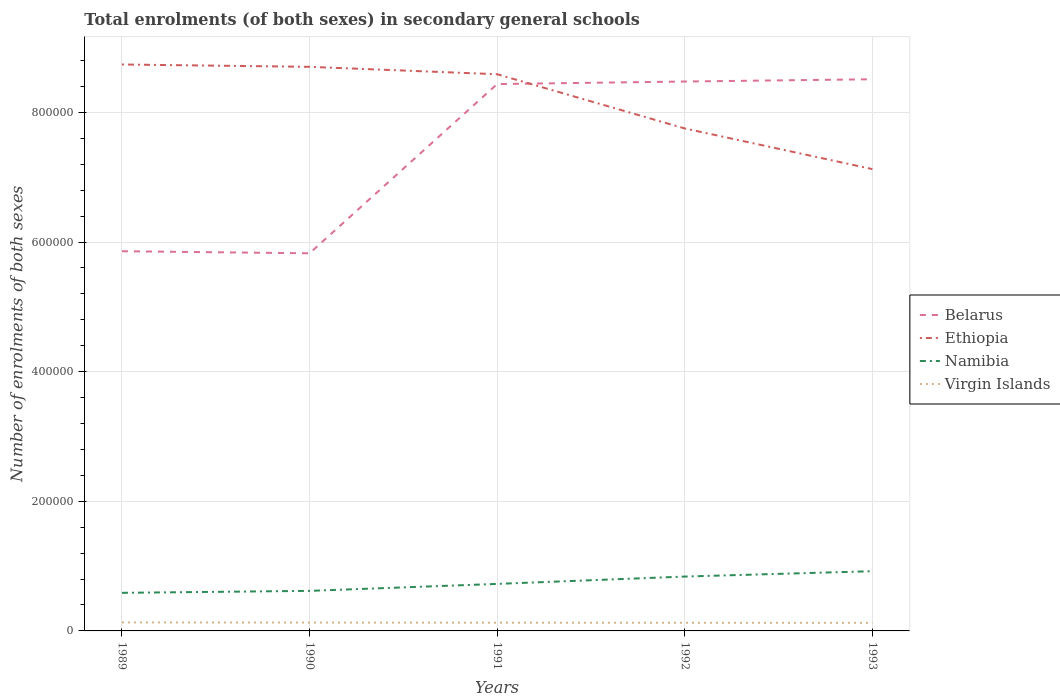Across all years, what is the maximum number of enrolments in secondary schools in Belarus?
Give a very brief answer. 5.83e+05. In which year was the number of enrolments in secondary schools in Namibia maximum?
Ensure brevity in your answer.  1989. What is the total number of enrolments in secondary schools in Namibia in the graph?
Offer a very short reply. -1.38e+04. What is the difference between the highest and the second highest number of enrolments in secondary schools in Namibia?
Make the answer very short. 3.34e+04. What is the difference between the highest and the lowest number of enrolments in secondary schools in Belarus?
Your response must be concise. 3. Is the number of enrolments in secondary schools in Belarus strictly greater than the number of enrolments in secondary schools in Ethiopia over the years?
Provide a succinct answer. No. How many legend labels are there?
Offer a terse response. 4. What is the title of the graph?
Your answer should be very brief. Total enrolments (of both sexes) in secondary general schools. Does "South Asia" appear as one of the legend labels in the graph?
Give a very brief answer. No. What is the label or title of the X-axis?
Offer a very short reply. Years. What is the label or title of the Y-axis?
Your answer should be compact. Number of enrolments of both sexes. What is the Number of enrolments of both sexes of Belarus in 1989?
Your answer should be very brief. 5.86e+05. What is the Number of enrolments of both sexes of Ethiopia in 1989?
Offer a terse response. 8.74e+05. What is the Number of enrolments of both sexes in Namibia in 1989?
Provide a short and direct response. 5.88e+04. What is the Number of enrolments of both sexes of Virgin Islands in 1989?
Keep it short and to the point. 1.31e+04. What is the Number of enrolments of both sexes in Belarus in 1990?
Your answer should be compact. 5.83e+05. What is the Number of enrolments of both sexes of Ethiopia in 1990?
Offer a very short reply. 8.70e+05. What is the Number of enrolments of both sexes in Namibia in 1990?
Give a very brief answer. 6.18e+04. What is the Number of enrolments of both sexes in Virgin Islands in 1990?
Give a very brief answer. 1.29e+04. What is the Number of enrolments of both sexes of Belarus in 1991?
Offer a terse response. 8.44e+05. What is the Number of enrolments of both sexes in Ethiopia in 1991?
Provide a short and direct response. 8.59e+05. What is the Number of enrolments of both sexes in Namibia in 1991?
Your answer should be very brief. 7.25e+04. What is the Number of enrolments of both sexes in Virgin Islands in 1991?
Your response must be concise. 1.27e+04. What is the Number of enrolments of both sexes in Belarus in 1992?
Your response must be concise. 8.48e+05. What is the Number of enrolments of both sexes in Ethiopia in 1992?
Your answer should be very brief. 7.75e+05. What is the Number of enrolments of both sexes in Namibia in 1992?
Ensure brevity in your answer.  8.39e+04. What is the Number of enrolments of both sexes of Virgin Islands in 1992?
Offer a very short reply. 1.26e+04. What is the Number of enrolments of both sexes of Belarus in 1993?
Provide a succinct answer. 8.51e+05. What is the Number of enrolments of both sexes of Ethiopia in 1993?
Provide a short and direct response. 7.12e+05. What is the Number of enrolments of both sexes of Namibia in 1993?
Your answer should be very brief. 9.21e+04. What is the Number of enrolments of both sexes of Virgin Islands in 1993?
Your answer should be very brief. 1.25e+04. Across all years, what is the maximum Number of enrolments of both sexes of Belarus?
Give a very brief answer. 8.51e+05. Across all years, what is the maximum Number of enrolments of both sexes of Ethiopia?
Your response must be concise. 8.74e+05. Across all years, what is the maximum Number of enrolments of both sexes of Namibia?
Provide a short and direct response. 9.21e+04. Across all years, what is the maximum Number of enrolments of both sexes of Virgin Islands?
Your answer should be compact. 1.31e+04. Across all years, what is the minimum Number of enrolments of both sexes in Belarus?
Keep it short and to the point. 5.83e+05. Across all years, what is the minimum Number of enrolments of both sexes in Ethiopia?
Your answer should be very brief. 7.12e+05. Across all years, what is the minimum Number of enrolments of both sexes of Namibia?
Offer a very short reply. 5.88e+04. Across all years, what is the minimum Number of enrolments of both sexes of Virgin Islands?
Provide a short and direct response. 1.25e+04. What is the total Number of enrolments of both sexes of Belarus in the graph?
Keep it short and to the point. 3.71e+06. What is the total Number of enrolments of both sexes in Ethiopia in the graph?
Give a very brief answer. 4.09e+06. What is the total Number of enrolments of both sexes in Namibia in the graph?
Keep it short and to the point. 3.69e+05. What is the total Number of enrolments of both sexes of Virgin Islands in the graph?
Offer a very short reply. 6.38e+04. What is the difference between the Number of enrolments of both sexes of Belarus in 1989 and that in 1990?
Make the answer very short. 3200. What is the difference between the Number of enrolments of both sexes of Ethiopia in 1989 and that in 1990?
Give a very brief answer. 3614. What is the difference between the Number of enrolments of both sexes of Namibia in 1989 and that in 1990?
Offer a terse response. -3032. What is the difference between the Number of enrolments of both sexes in Belarus in 1989 and that in 1991?
Your response must be concise. -2.58e+05. What is the difference between the Number of enrolments of both sexes in Ethiopia in 1989 and that in 1991?
Your answer should be very brief. 1.50e+04. What is the difference between the Number of enrolments of both sexes of Namibia in 1989 and that in 1991?
Keep it short and to the point. -1.38e+04. What is the difference between the Number of enrolments of both sexes of Belarus in 1989 and that in 1992?
Give a very brief answer. -2.62e+05. What is the difference between the Number of enrolments of both sexes of Ethiopia in 1989 and that in 1992?
Provide a short and direct response. 9.87e+04. What is the difference between the Number of enrolments of both sexes in Namibia in 1989 and that in 1992?
Your answer should be very brief. -2.51e+04. What is the difference between the Number of enrolments of both sexes in Virgin Islands in 1989 and that in 1992?
Your answer should be compact. 500. What is the difference between the Number of enrolments of both sexes of Belarus in 1989 and that in 1993?
Give a very brief answer. -2.65e+05. What is the difference between the Number of enrolments of both sexes in Ethiopia in 1989 and that in 1993?
Provide a short and direct response. 1.61e+05. What is the difference between the Number of enrolments of both sexes in Namibia in 1989 and that in 1993?
Your answer should be compact. -3.34e+04. What is the difference between the Number of enrolments of both sexes of Virgin Islands in 1989 and that in 1993?
Provide a succinct answer. 598. What is the difference between the Number of enrolments of both sexes in Belarus in 1990 and that in 1991?
Your response must be concise. -2.61e+05. What is the difference between the Number of enrolments of both sexes of Ethiopia in 1990 and that in 1991?
Your answer should be compact. 1.14e+04. What is the difference between the Number of enrolments of both sexes in Namibia in 1990 and that in 1991?
Your answer should be compact. -1.07e+04. What is the difference between the Number of enrolments of both sexes in Belarus in 1990 and that in 1992?
Offer a terse response. -2.65e+05. What is the difference between the Number of enrolments of both sexes of Ethiopia in 1990 and that in 1992?
Provide a short and direct response. 9.51e+04. What is the difference between the Number of enrolments of both sexes of Namibia in 1990 and that in 1992?
Keep it short and to the point. -2.21e+04. What is the difference between the Number of enrolments of both sexes in Virgin Islands in 1990 and that in 1992?
Offer a very short reply. 300. What is the difference between the Number of enrolments of both sexes in Belarus in 1990 and that in 1993?
Make the answer very short. -2.68e+05. What is the difference between the Number of enrolments of both sexes of Ethiopia in 1990 and that in 1993?
Make the answer very short. 1.58e+05. What is the difference between the Number of enrolments of both sexes in Namibia in 1990 and that in 1993?
Your answer should be very brief. -3.03e+04. What is the difference between the Number of enrolments of both sexes in Virgin Islands in 1990 and that in 1993?
Offer a very short reply. 398. What is the difference between the Number of enrolments of both sexes of Belarus in 1991 and that in 1992?
Provide a succinct answer. -3900. What is the difference between the Number of enrolments of both sexes in Ethiopia in 1991 and that in 1992?
Your response must be concise. 8.36e+04. What is the difference between the Number of enrolments of both sexes of Namibia in 1991 and that in 1992?
Your response must be concise. -1.13e+04. What is the difference between the Number of enrolments of both sexes in Belarus in 1991 and that in 1993?
Ensure brevity in your answer.  -7400. What is the difference between the Number of enrolments of both sexes of Ethiopia in 1991 and that in 1993?
Keep it short and to the point. 1.46e+05. What is the difference between the Number of enrolments of both sexes in Namibia in 1991 and that in 1993?
Provide a succinct answer. -1.96e+04. What is the difference between the Number of enrolments of both sexes in Virgin Islands in 1991 and that in 1993?
Offer a very short reply. 198. What is the difference between the Number of enrolments of both sexes in Belarus in 1992 and that in 1993?
Keep it short and to the point. -3500. What is the difference between the Number of enrolments of both sexes of Ethiopia in 1992 and that in 1993?
Provide a short and direct response. 6.27e+04. What is the difference between the Number of enrolments of both sexes in Namibia in 1992 and that in 1993?
Keep it short and to the point. -8274. What is the difference between the Number of enrolments of both sexes in Virgin Islands in 1992 and that in 1993?
Offer a very short reply. 98. What is the difference between the Number of enrolments of both sexes of Belarus in 1989 and the Number of enrolments of both sexes of Ethiopia in 1990?
Ensure brevity in your answer.  -2.84e+05. What is the difference between the Number of enrolments of both sexes of Belarus in 1989 and the Number of enrolments of both sexes of Namibia in 1990?
Offer a very short reply. 5.24e+05. What is the difference between the Number of enrolments of both sexes of Belarus in 1989 and the Number of enrolments of both sexes of Virgin Islands in 1990?
Offer a terse response. 5.73e+05. What is the difference between the Number of enrolments of both sexes of Ethiopia in 1989 and the Number of enrolments of both sexes of Namibia in 1990?
Ensure brevity in your answer.  8.12e+05. What is the difference between the Number of enrolments of both sexes in Ethiopia in 1989 and the Number of enrolments of both sexes in Virgin Islands in 1990?
Provide a short and direct response. 8.61e+05. What is the difference between the Number of enrolments of both sexes of Namibia in 1989 and the Number of enrolments of both sexes of Virgin Islands in 1990?
Keep it short and to the point. 4.59e+04. What is the difference between the Number of enrolments of both sexes in Belarus in 1989 and the Number of enrolments of both sexes in Ethiopia in 1991?
Offer a terse response. -2.73e+05. What is the difference between the Number of enrolments of both sexes in Belarus in 1989 and the Number of enrolments of both sexes in Namibia in 1991?
Your answer should be compact. 5.13e+05. What is the difference between the Number of enrolments of both sexes of Belarus in 1989 and the Number of enrolments of both sexes of Virgin Islands in 1991?
Your answer should be very brief. 5.73e+05. What is the difference between the Number of enrolments of both sexes in Ethiopia in 1989 and the Number of enrolments of both sexes in Namibia in 1991?
Offer a terse response. 8.01e+05. What is the difference between the Number of enrolments of both sexes of Ethiopia in 1989 and the Number of enrolments of both sexes of Virgin Islands in 1991?
Keep it short and to the point. 8.61e+05. What is the difference between the Number of enrolments of both sexes of Namibia in 1989 and the Number of enrolments of both sexes of Virgin Islands in 1991?
Your answer should be very brief. 4.61e+04. What is the difference between the Number of enrolments of both sexes in Belarus in 1989 and the Number of enrolments of both sexes in Ethiopia in 1992?
Ensure brevity in your answer.  -1.89e+05. What is the difference between the Number of enrolments of both sexes in Belarus in 1989 and the Number of enrolments of both sexes in Namibia in 1992?
Your response must be concise. 5.02e+05. What is the difference between the Number of enrolments of both sexes of Belarus in 1989 and the Number of enrolments of both sexes of Virgin Islands in 1992?
Make the answer very short. 5.73e+05. What is the difference between the Number of enrolments of both sexes of Ethiopia in 1989 and the Number of enrolments of both sexes of Namibia in 1992?
Your answer should be very brief. 7.90e+05. What is the difference between the Number of enrolments of both sexes of Ethiopia in 1989 and the Number of enrolments of both sexes of Virgin Islands in 1992?
Provide a short and direct response. 8.61e+05. What is the difference between the Number of enrolments of both sexes in Namibia in 1989 and the Number of enrolments of both sexes in Virgin Islands in 1992?
Provide a short and direct response. 4.62e+04. What is the difference between the Number of enrolments of both sexes of Belarus in 1989 and the Number of enrolments of both sexes of Ethiopia in 1993?
Your answer should be very brief. -1.27e+05. What is the difference between the Number of enrolments of both sexes of Belarus in 1989 and the Number of enrolments of both sexes of Namibia in 1993?
Keep it short and to the point. 4.94e+05. What is the difference between the Number of enrolments of both sexes of Belarus in 1989 and the Number of enrolments of both sexes of Virgin Islands in 1993?
Give a very brief answer. 5.73e+05. What is the difference between the Number of enrolments of both sexes in Ethiopia in 1989 and the Number of enrolments of both sexes in Namibia in 1993?
Keep it short and to the point. 7.82e+05. What is the difference between the Number of enrolments of both sexes of Ethiopia in 1989 and the Number of enrolments of both sexes of Virgin Islands in 1993?
Ensure brevity in your answer.  8.61e+05. What is the difference between the Number of enrolments of both sexes of Namibia in 1989 and the Number of enrolments of both sexes of Virgin Islands in 1993?
Your answer should be compact. 4.63e+04. What is the difference between the Number of enrolments of both sexes in Belarus in 1990 and the Number of enrolments of both sexes in Ethiopia in 1991?
Give a very brief answer. -2.76e+05. What is the difference between the Number of enrolments of both sexes in Belarus in 1990 and the Number of enrolments of both sexes in Namibia in 1991?
Offer a terse response. 5.10e+05. What is the difference between the Number of enrolments of both sexes in Belarus in 1990 and the Number of enrolments of both sexes in Virgin Islands in 1991?
Give a very brief answer. 5.70e+05. What is the difference between the Number of enrolments of both sexes in Ethiopia in 1990 and the Number of enrolments of both sexes in Namibia in 1991?
Make the answer very short. 7.98e+05. What is the difference between the Number of enrolments of both sexes of Ethiopia in 1990 and the Number of enrolments of both sexes of Virgin Islands in 1991?
Your answer should be compact. 8.58e+05. What is the difference between the Number of enrolments of both sexes of Namibia in 1990 and the Number of enrolments of both sexes of Virgin Islands in 1991?
Your answer should be compact. 4.91e+04. What is the difference between the Number of enrolments of both sexes of Belarus in 1990 and the Number of enrolments of both sexes of Ethiopia in 1992?
Your response must be concise. -1.93e+05. What is the difference between the Number of enrolments of both sexes of Belarus in 1990 and the Number of enrolments of both sexes of Namibia in 1992?
Your response must be concise. 4.99e+05. What is the difference between the Number of enrolments of both sexes of Belarus in 1990 and the Number of enrolments of both sexes of Virgin Islands in 1992?
Give a very brief answer. 5.70e+05. What is the difference between the Number of enrolments of both sexes of Ethiopia in 1990 and the Number of enrolments of both sexes of Namibia in 1992?
Offer a very short reply. 7.86e+05. What is the difference between the Number of enrolments of both sexes in Ethiopia in 1990 and the Number of enrolments of both sexes in Virgin Islands in 1992?
Make the answer very short. 8.58e+05. What is the difference between the Number of enrolments of both sexes of Namibia in 1990 and the Number of enrolments of both sexes of Virgin Islands in 1992?
Provide a short and direct response. 4.92e+04. What is the difference between the Number of enrolments of both sexes of Belarus in 1990 and the Number of enrolments of both sexes of Ethiopia in 1993?
Give a very brief answer. -1.30e+05. What is the difference between the Number of enrolments of both sexes of Belarus in 1990 and the Number of enrolments of both sexes of Namibia in 1993?
Provide a succinct answer. 4.90e+05. What is the difference between the Number of enrolments of both sexes of Belarus in 1990 and the Number of enrolments of both sexes of Virgin Islands in 1993?
Offer a very short reply. 5.70e+05. What is the difference between the Number of enrolments of both sexes of Ethiopia in 1990 and the Number of enrolments of both sexes of Namibia in 1993?
Keep it short and to the point. 7.78e+05. What is the difference between the Number of enrolments of both sexes in Ethiopia in 1990 and the Number of enrolments of both sexes in Virgin Islands in 1993?
Provide a short and direct response. 8.58e+05. What is the difference between the Number of enrolments of both sexes in Namibia in 1990 and the Number of enrolments of both sexes in Virgin Islands in 1993?
Ensure brevity in your answer.  4.93e+04. What is the difference between the Number of enrolments of both sexes in Belarus in 1991 and the Number of enrolments of both sexes in Ethiopia in 1992?
Give a very brief answer. 6.85e+04. What is the difference between the Number of enrolments of both sexes of Belarus in 1991 and the Number of enrolments of both sexes of Namibia in 1992?
Your answer should be very brief. 7.60e+05. What is the difference between the Number of enrolments of both sexes of Belarus in 1991 and the Number of enrolments of both sexes of Virgin Islands in 1992?
Offer a terse response. 8.31e+05. What is the difference between the Number of enrolments of both sexes in Ethiopia in 1991 and the Number of enrolments of both sexes in Namibia in 1992?
Keep it short and to the point. 7.75e+05. What is the difference between the Number of enrolments of both sexes in Ethiopia in 1991 and the Number of enrolments of both sexes in Virgin Islands in 1992?
Your answer should be very brief. 8.46e+05. What is the difference between the Number of enrolments of both sexes in Namibia in 1991 and the Number of enrolments of both sexes in Virgin Islands in 1992?
Provide a short and direct response. 5.99e+04. What is the difference between the Number of enrolments of both sexes of Belarus in 1991 and the Number of enrolments of both sexes of Ethiopia in 1993?
Your answer should be very brief. 1.31e+05. What is the difference between the Number of enrolments of both sexes in Belarus in 1991 and the Number of enrolments of both sexes in Namibia in 1993?
Your response must be concise. 7.52e+05. What is the difference between the Number of enrolments of both sexes in Belarus in 1991 and the Number of enrolments of both sexes in Virgin Islands in 1993?
Offer a terse response. 8.31e+05. What is the difference between the Number of enrolments of both sexes of Ethiopia in 1991 and the Number of enrolments of both sexes of Namibia in 1993?
Give a very brief answer. 7.67e+05. What is the difference between the Number of enrolments of both sexes of Ethiopia in 1991 and the Number of enrolments of both sexes of Virgin Islands in 1993?
Provide a short and direct response. 8.46e+05. What is the difference between the Number of enrolments of both sexes of Namibia in 1991 and the Number of enrolments of both sexes of Virgin Islands in 1993?
Your answer should be compact. 6.00e+04. What is the difference between the Number of enrolments of both sexes of Belarus in 1992 and the Number of enrolments of both sexes of Ethiopia in 1993?
Offer a terse response. 1.35e+05. What is the difference between the Number of enrolments of both sexes in Belarus in 1992 and the Number of enrolments of both sexes in Namibia in 1993?
Your answer should be compact. 7.55e+05. What is the difference between the Number of enrolments of both sexes in Belarus in 1992 and the Number of enrolments of both sexes in Virgin Islands in 1993?
Keep it short and to the point. 8.35e+05. What is the difference between the Number of enrolments of both sexes of Ethiopia in 1992 and the Number of enrolments of both sexes of Namibia in 1993?
Your response must be concise. 6.83e+05. What is the difference between the Number of enrolments of both sexes in Ethiopia in 1992 and the Number of enrolments of both sexes in Virgin Islands in 1993?
Your response must be concise. 7.63e+05. What is the difference between the Number of enrolments of both sexes in Namibia in 1992 and the Number of enrolments of both sexes in Virgin Islands in 1993?
Provide a short and direct response. 7.14e+04. What is the average Number of enrolments of both sexes of Belarus per year?
Offer a terse response. 7.42e+05. What is the average Number of enrolments of both sexes in Ethiopia per year?
Provide a succinct answer. 8.18e+05. What is the average Number of enrolments of both sexes in Namibia per year?
Your response must be concise. 7.38e+04. What is the average Number of enrolments of both sexes in Virgin Islands per year?
Provide a short and direct response. 1.28e+04. In the year 1989, what is the difference between the Number of enrolments of both sexes in Belarus and Number of enrolments of both sexes in Ethiopia?
Offer a terse response. -2.88e+05. In the year 1989, what is the difference between the Number of enrolments of both sexes in Belarus and Number of enrolments of both sexes in Namibia?
Provide a short and direct response. 5.27e+05. In the year 1989, what is the difference between the Number of enrolments of both sexes of Belarus and Number of enrolments of both sexes of Virgin Islands?
Provide a short and direct response. 5.73e+05. In the year 1989, what is the difference between the Number of enrolments of both sexes of Ethiopia and Number of enrolments of both sexes of Namibia?
Your answer should be compact. 8.15e+05. In the year 1989, what is the difference between the Number of enrolments of both sexes in Ethiopia and Number of enrolments of both sexes in Virgin Islands?
Your answer should be very brief. 8.61e+05. In the year 1989, what is the difference between the Number of enrolments of both sexes in Namibia and Number of enrolments of both sexes in Virgin Islands?
Offer a terse response. 4.57e+04. In the year 1990, what is the difference between the Number of enrolments of both sexes in Belarus and Number of enrolments of both sexes in Ethiopia?
Ensure brevity in your answer.  -2.88e+05. In the year 1990, what is the difference between the Number of enrolments of both sexes of Belarus and Number of enrolments of both sexes of Namibia?
Ensure brevity in your answer.  5.21e+05. In the year 1990, what is the difference between the Number of enrolments of both sexes in Belarus and Number of enrolments of both sexes in Virgin Islands?
Provide a short and direct response. 5.70e+05. In the year 1990, what is the difference between the Number of enrolments of both sexes of Ethiopia and Number of enrolments of both sexes of Namibia?
Offer a very short reply. 8.08e+05. In the year 1990, what is the difference between the Number of enrolments of both sexes of Ethiopia and Number of enrolments of both sexes of Virgin Islands?
Your response must be concise. 8.57e+05. In the year 1990, what is the difference between the Number of enrolments of both sexes of Namibia and Number of enrolments of both sexes of Virgin Islands?
Provide a short and direct response. 4.89e+04. In the year 1991, what is the difference between the Number of enrolments of both sexes of Belarus and Number of enrolments of both sexes of Ethiopia?
Offer a very short reply. -1.51e+04. In the year 1991, what is the difference between the Number of enrolments of both sexes in Belarus and Number of enrolments of both sexes in Namibia?
Keep it short and to the point. 7.71e+05. In the year 1991, what is the difference between the Number of enrolments of both sexes of Belarus and Number of enrolments of both sexes of Virgin Islands?
Provide a short and direct response. 8.31e+05. In the year 1991, what is the difference between the Number of enrolments of both sexes of Ethiopia and Number of enrolments of both sexes of Namibia?
Your response must be concise. 7.86e+05. In the year 1991, what is the difference between the Number of enrolments of both sexes in Ethiopia and Number of enrolments of both sexes in Virgin Islands?
Keep it short and to the point. 8.46e+05. In the year 1991, what is the difference between the Number of enrolments of both sexes in Namibia and Number of enrolments of both sexes in Virgin Islands?
Your answer should be compact. 5.98e+04. In the year 1992, what is the difference between the Number of enrolments of both sexes of Belarus and Number of enrolments of both sexes of Ethiopia?
Your response must be concise. 7.24e+04. In the year 1992, what is the difference between the Number of enrolments of both sexes of Belarus and Number of enrolments of both sexes of Namibia?
Your answer should be compact. 7.64e+05. In the year 1992, what is the difference between the Number of enrolments of both sexes in Belarus and Number of enrolments of both sexes in Virgin Islands?
Ensure brevity in your answer.  8.35e+05. In the year 1992, what is the difference between the Number of enrolments of both sexes in Ethiopia and Number of enrolments of both sexes in Namibia?
Make the answer very short. 6.91e+05. In the year 1992, what is the difference between the Number of enrolments of both sexes in Ethiopia and Number of enrolments of both sexes in Virgin Islands?
Offer a terse response. 7.63e+05. In the year 1992, what is the difference between the Number of enrolments of both sexes in Namibia and Number of enrolments of both sexes in Virgin Islands?
Provide a short and direct response. 7.13e+04. In the year 1993, what is the difference between the Number of enrolments of both sexes in Belarus and Number of enrolments of both sexes in Ethiopia?
Your answer should be very brief. 1.39e+05. In the year 1993, what is the difference between the Number of enrolments of both sexes in Belarus and Number of enrolments of both sexes in Namibia?
Your answer should be very brief. 7.59e+05. In the year 1993, what is the difference between the Number of enrolments of both sexes of Belarus and Number of enrolments of both sexes of Virgin Islands?
Offer a very short reply. 8.39e+05. In the year 1993, what is the difference between the Number of enrolments of both sexes in Ethiopia and Number of enrolments of both sexes in Namibia?
Provide a short and direct response. 6.20e+05. In the year 1993, what is the difference between the Number of enrolments of both sexes in Ethiopia and Number of enrolments of both sexes in Virgin Islands?
Your answer should be compact. 7.00e+05. In the year 1993, what is the difference between the Number of enrolments of both sexes of Namibia and Number of enrolments of both sexes of Virgin Islands?
Your answer should be compact. 7.96e+04. What is the ratio of the Number of enrolments of both sexes in Ethiopia in 1989 to that in 1990?
Offer a very short reply. 1. What is the ratio of the Number of enrolments of both sexes in Namibia in 1989 to that in 1990?
Ensure brevity in your answer.  0.95. What is the ratio of the Number of enrolments of both sexes of Virgin Islands in 1989 to that in 1990?
Keep it short and to the point. 1.02. What is the ratio of the Number of enrolments of both sexes of Belarus in 1989 to that in 1991?
Your answer should be compact. 0.69. What is the ratio of the Number of enrolments of both sexes in Ethiopia in 1989 to that in 1991?
Your response must be concise. 1.02. What is the ratio of the Number of enrolments of both sexes in Namibia in 1989 to that in 1991?
Your response must be concise. 0.81. What is the ratio of the Number of enrolments of both sexes of Virgin Islands in 1989 to that in 1991?
Your answer should be very brief. 1.03. What is the ratio of the Number of enrolments of both sexes in Belarus in 1989 to that in 1992?
Give a very brief answer. 0.69. What is the ratio of the Number of enrolments of both sexes in Ethiopia in 1989 to that in 1992?
Ensure brevity in your answer.  1.13. What is the ratio of the Number of enrolments of both sexes of Namibia in 1989 to that in 1992?
Keep it short and to the point. 0.7. What is the ratio of the Number of enrolments of both sexes of Virgin Islands in 1989 to that in 1992?
Offer a very short reply. 1.04. What is the ratio of the Number of enrolments of both sexes in Belarus in 1989 to that in 1993?
Offer a terse response. 0.69. What is the ratio of the Number of enrolments of both sexes in Ethiopia in 1989 to that in 1993?
Your response must be concise. 1.23. What is the ratio of the Number of enrolments of both sexes in Namibia in 1989 to that in 1993?
Your answer should be compact. 0.64. What is the ratio of the Number of enrolments of both sexes of Virgin Islands in 1989 to that in 1993?
Your answer should be very brief. 1.05. What is the ratio of the Number of enrolments of both sexes in Belarus in 1990 to that in 1991?
Provide a succinct answer. 0.69. What is the ratio of the Number of enrolments of both sexes of Ethiopia in 1990 to that in 1991?
Provide a succinct answer. 1.01. What is the ratio of the Number of enrolments of both sexes of Namibia in 1990 to that in 1991?
Make the answer very short. 0.85. What is the ratio of the Number of enrolments of both sexes of Virgin Islands in 1990 to that in 1991?
Provide a short and direct response. 1.02. What is the ratio of the Number of enrolments of both sexes in Belarus in 1990 to that in 1992?
Keep it short and to the point. 0.69. What is the ratio of the Number of enrolments of both sexes of Ethiopia in 1990 to that in 1992?
Give a very brief answer. 1.12. What is the ratio of the Number of enrolments of both sexes of Namibia in 1990 to that in 1992?
Ensure brevity in your answer.  0.74. What is the ratio of the Number of enrolments of both sexes of Virgin Islands in 1990 to that in 1992?
Give a very brief answer. 1.02. What is the ratio of the Number of enrolments of both sexes in Belarus in 1990 to that in 1993?
Your answer should be very brief. 0.68. What is the ratio of the Number of enrolments of both sexes of Ethiopia in 1990 to that in 1993?
Your answer should be very brief. 1.22. What is the ratio of the Number of enrolments of both sexes in Namibia in 1990 to that in 1993?
Your answer should be compact. 0.67. What is the ratio of the Number of enrolments of both sexes in Virgin Islands in 1990 to that in 1993?
Provide a short and direct response. 1.03. What is the ratio of the Number of enrolments of both sexes of Belarus in 1991 to that in 1992?
Provide a short and direct response. 1. What is the ratio of the Number of enrolments of both sexes in Ethiopia in 1991 to that in 1992?
Provide a short and direct response. 1.11. What is the ratio of the Number of enrolments of both sexes in Namibia in 1991 to that in 1992?
Make the answer very short. 0.86. What is the ratio of the Number of enrolments of both sexes of Virgin Islands in 1991 to that in 1992?
Make the answer very short. 1.01. What is the ratio of the Number of enrolments of both sexes in Ethiopia in 1991 to that in 1993?
Give a very brief answer. 1.21. What is the ratio of the Number of enrolments of both sexes in Namibia in 1991 to that in 1993?
Offer a very short reply. 0.79. What is the ratio of the Number of enrolments of both sexes in Virgin Islands in 1991 to that in 1993?
Provide a short and direct response. 1.02. What is the ratio of the Number of enrolments of both sexes in Ethiopia in 1992 to that in 1993?
Keep it short and to the point. 1.09. What is the ratio of the Number of enrolments of both sexes of Namibia in 1992 to that in 1993?
Make the answer very short. 0.91. What is the difference between the highest and the second highest Number of enrolments of both sexes in Belarus?
Your answer should be compact. 3500. What is the difference between the highest and the second highest Number of enrolments of both sexes in Ethiopia?
Provide a short and direct response. 3614. What is the difference between the highest and the second highest Number of enrolments of both sexes in Namibia?
Your response must be concise. 8274. What is the difference between the highest and the second highest Number of enrolments of both sexes in Virgin Islands?
Ensure brevity in your answer.  200. What is the difference between the highest and the lowest Number of enrolments of both sexes in Belarus?
Your response must be concise. 2.68e+05. What is the difference between the highest and the lowest Number of enrolments of both sexes of Ethiopia?
Make the answer very short. 1.61e+05. What is the difference between the highest and the lowest Number of enrolments of both sexes in Namibia?
Provide a short and direct response. 3.34e+04. What is the difference between the highest and the lowest Number of enrolments of both sexes in Virgin Islands?
Offer a very short reply. 598. 